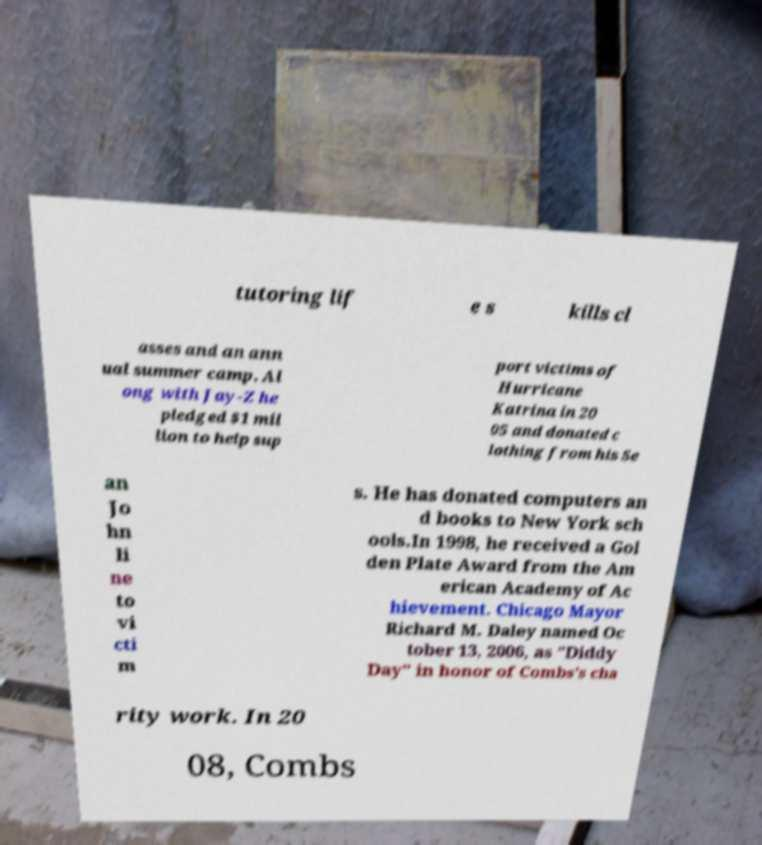Can you accurately transcribe the text from the provided image for me? tutoring lif e s kills cl asses and an ann ual summer camp. Al ong with Jay-Z he pledged $1 mil lion to help sup port victims of Hurricane Katrina in 20 05 and donated c lothing from his Se an Jo hn li ne to vi cti m s. He has donated computers an d books to New York sch ools.In 1998, he received a Gol den Plate Award from the Am erican Academy of Ac hievement. Chicago Mayor Richard M. Daley named Oc tober 13, 2006, as "Diddy Day" in honor of Combs's cha rity work. In 20 08, Combs 